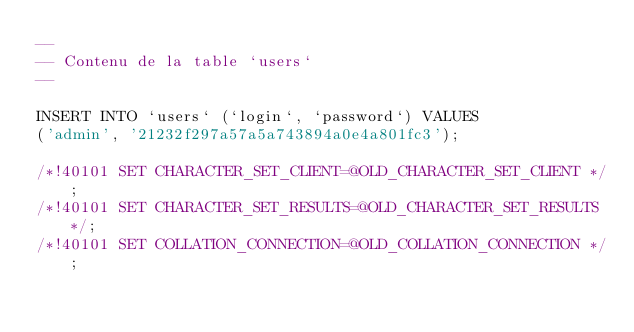Convert code to text. <code><loc_0><loc_0><loc_500><loc_500><_SQL_>--
-- Contenu de la table `users`
--

INSERT INTO `users` (`login`, `password`) VALUES
('admin', '21232f297a57a5a743894a0e4a801fc3');

/*!40101 SET CHARACTER_SET_CLIENT=@OLD_CHARACTER_SET_CLIENT */;
/*!40101 SET CHARACTER_SET_RESULTS=@OLD_CHARACTER_SET_RESULTS */;
/*!40101 SET COLLATION_CONNECTION=@OLD_COLLATION_CONNECTION */;
</code> 